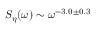<formula> <loc_0><loc_0><loc_500><loc_500>S _ { \eta } ( \omega ) \sim \omega ^ { - 3 . 0 \pm 0 . 3 }</formula> 